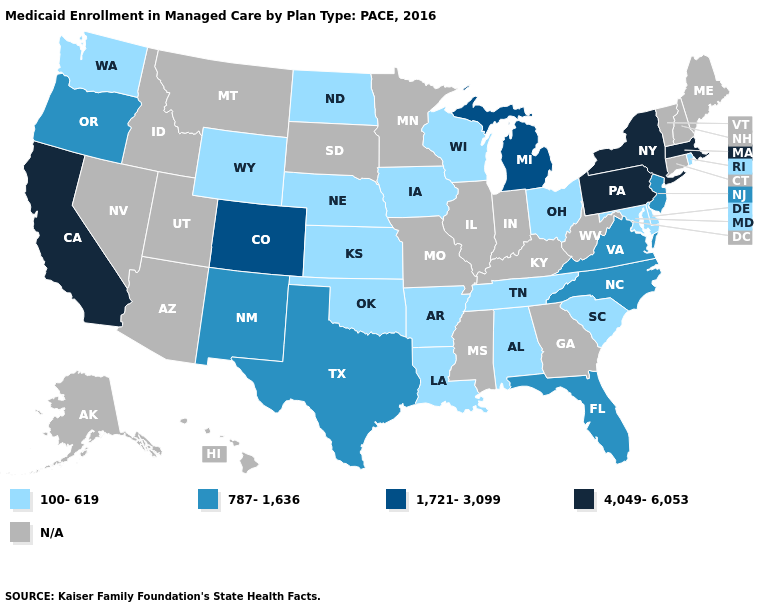Among the states that border Alabama , which have the highest value?
Short answer required. Florida. Does the map have missing data?
Concise answer only. Yes. Among the states that border Alabama , does Florida have the highest value?
Write a very short answer. Yes. Name the states that have a value in the range 4,049-6,053?
Give a very brief answer. California, Massachusetts, New York, Pennsylvania. Name the states that have a value in the range 100-619?
Short answer required. Alabama, Arkansas, Delaware, Iowa, Kansas, Louisiana, Maryland, Nebraska, North Dakota, Ohio, Oklahoma, Rhode Island, South Carolina, Tennessee, Washington, Wisconsin, Wyoming. Does New Jersey have the lowest value in the USA?
Answer briefly. No. What is the value of Michigan?
Write a very short answer. 1,721-3,099. What is the value of Montana?
Concise answer only. N/A. What is the lowest value in the USA?
Quick response, please. 100-619. Which states have the lowest value in the Northeast?
Be succinct. Rhode Island. Name the states that have a value in the range 787-1,636?
Be succinct. Florida, New Jersey, New Mexico, North Carolina, Oregon, Texas, Virginia. Among the states that border Alabama , which have the highest value?
Answer briefly. Florida. Which states have the lowest value in the West?
Concise answer only. Washington, Wyoming. 